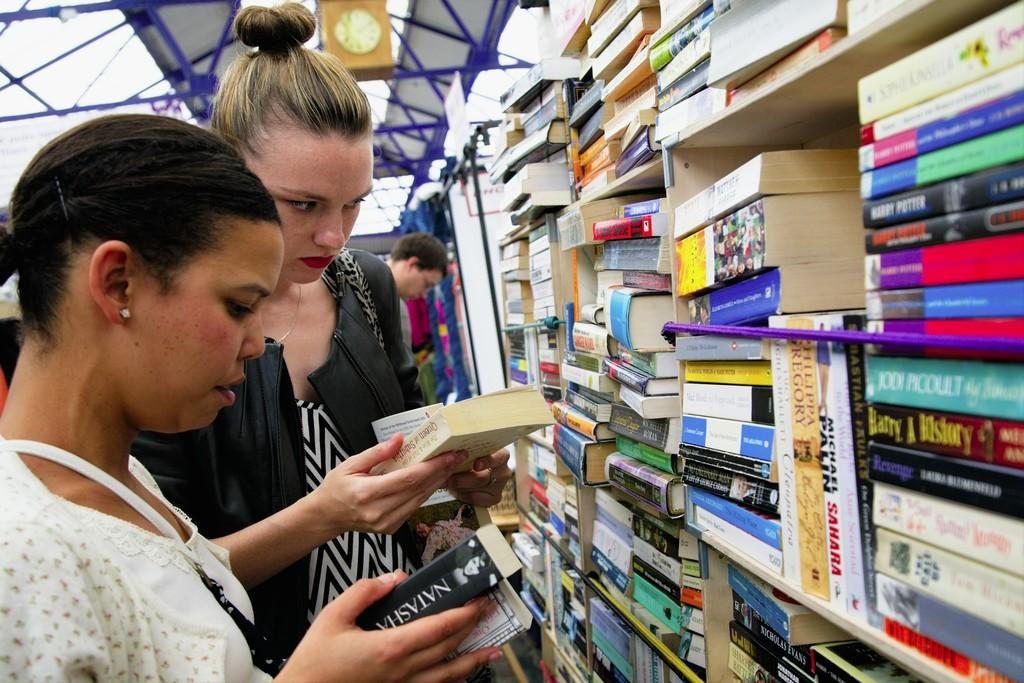<image>
Give a short and clear explanation of the subsequent image. A woman is holding a book with Natasha on the side of it. 